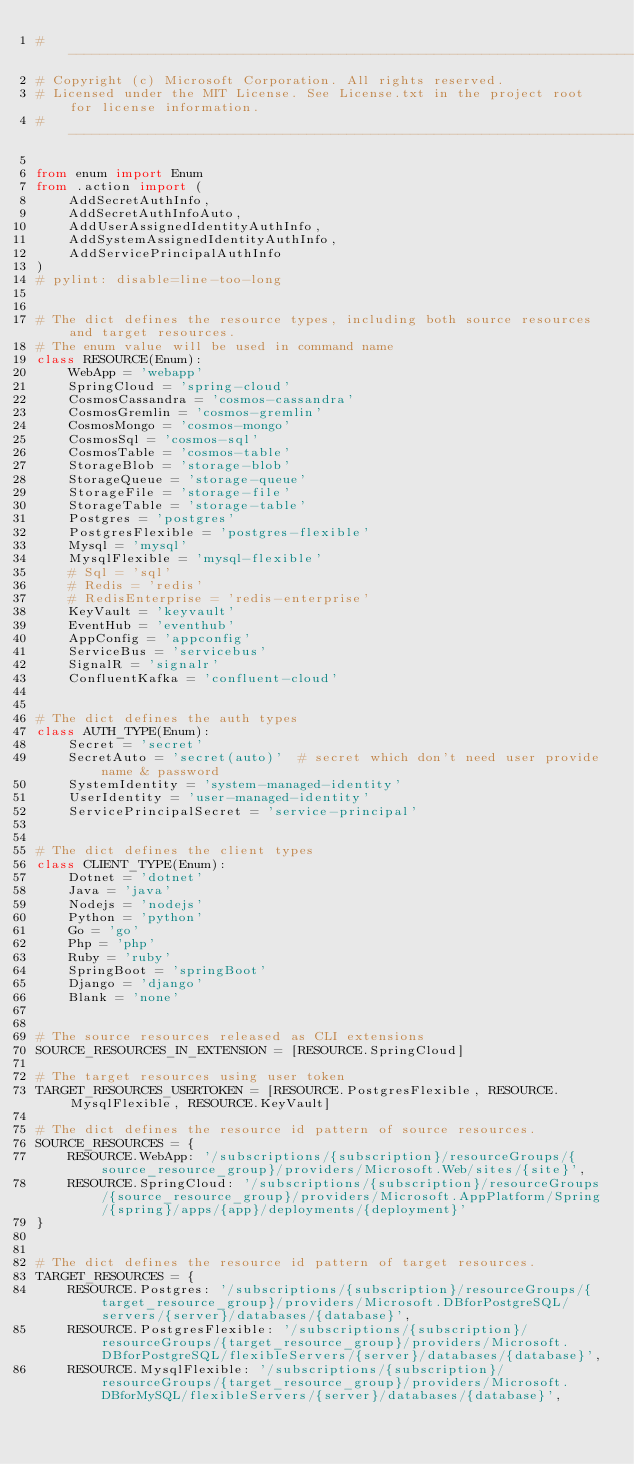Convert code to text. <code><loc_0><loc_0><loc_500><loc_500><_Python_># --------------------------------------------------------------------------------------------
# Copyright (c) Microsoft Corporation. All rights reserved.
# Licensed under the MIT License. See License.txt in the project root for license information.
# --------------------------------------------------------------------------------------------

from enum import Enum
from .action import (
    AddSecretAuthInfo,
    AddSecretAuthInfoAuto,
    AddUserAssignedIdentityAuthInfo,
    AddSystemAssignedIdentityAuthInfo,
    AddServicePrincipalAuthInfo
)
# pylint: disable=line-too-long


# The dict defines the resource types, including both source resources and target resources.
# The enum value will be used in command name
class RESOURCE(Enum):
    WebApp = 'webapp'
    SpringCloud = 'spring-cloud'
    CosmosCassandra = 'cosmos-cassandra'
    CosmosGremlin = 'cosmos-gremlin'
    CosmosMongo = 'cosmos-mongo'
    CosmosSql = 'cosmos-sql'
    CosmosTable = 'cosmos-table'
    StorageBlob = 'storage-blob'
    StorageQueue = 'storage-queue'
    StorageFile = 'storage-file'
    StorageTable = 'storage-table'
    Postgres = 'postgres'
    PostgresFlexible = 'postgres-flexible'
    Mysql = 'mysql'
    MysqlFlexible = 'mysql-flexible'
    # Sql = 'sql'
    # Redis = 'redis'
    # RedisEnterprise = 'redis-enterprise'
    KeyVault = 'keyvault'
    EventHub = 'eventhub'
    AppConfig = 'appconfig'
    ServiceBus = 'servicebus'
    SignalR = 'signalr'
    ConfluentKafka = 'confluent-cloud'


# The dict defines the auth types
class AUTH_TYPE(Enum):
    Secret = 'secret'
    SecretAuto = 'secret(auto)'  # secret which don't need user provide name & password
    SystemIdentity = 'system-managed-identity'
    UserIdentity = 'user-managed-identity'
    ServicePrincipalSecret = 'service-principal'


# The dict defines the client types
class CLIENT_TYPE(Enum):
    Dotnet = 'dotnet'
    Java = 'java'
    Nodejs = 'nodejs'
    Python = 'python'
    Go = 'go'
    Php = 'php'
    Ruby = 'ruby'
    SpringBoot = 'springBoot'
    Django = 'django'
    Blank = 'none'


# The source resources released as CLI extensions
SOURCE_RESOURCES_IN_EXTENSION = [RESOURCE.SpringCloud]

# The target resources using user token
TARGET_RESOURCES_USERTOKEN = [RESOURCE.PostgresFlexible, RESOURCE.MysqlFlexible, RESOURCE.KeyVault]

# The dict defines the resource id pattern of source resources.
SOURCE_RESOURCES = {
    RESOURCE.WebApp: '/subscriptions/{subscription}/resourceGroups/{source_resource_group}/providers/Microsoft.Web/sites/{site}',
    RESOURCE.SpringCloud: '/subscriptions/{subscription}/resourceGroups/{source_resource_group}/providers/Microsoft.AppPlatform/Spring/{spring}/apps/{app}/deployments/{deployment}'
}


# The dict defines the resource id pattern of target resources.
TARGET_RESOURCES = {
    RESOURCE.Postgres: '/subscriptions/{subscription}/resourceGroups/{target_resource_group}/providers/Microsoft.DBforPostgreSQL/servers/{server}/databases/{database}',
    RESOURCE.PostgresFlexible: '/subscriptions/{subscription}/resourceGroups/{target_resource_group}/providers/Microsoft.DBforPostgreSQL/flexibleServers/{server}/databases/{database}',
    RESOURCE.MysqlFlexible: '/subscriptions/{subscription}/resourceGroups/{target_resource_group}/providers/Microsoft.DBforMySQL/flexibleServers/{server}/databases/{database}',</code> 